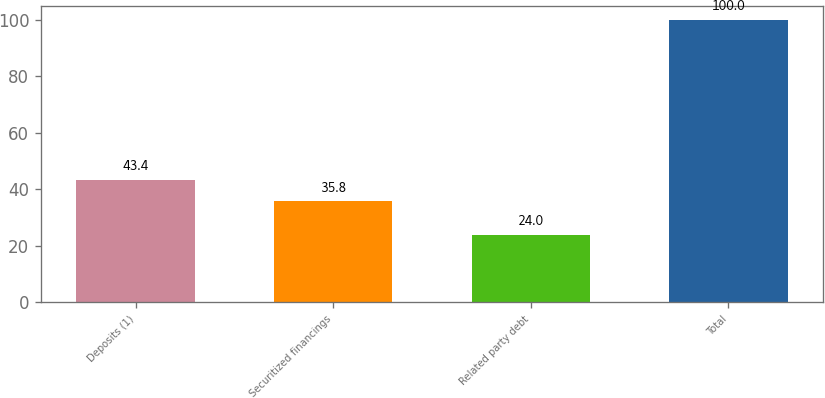Convert chart. <chart><loc_0><loc_0><loc_500><loc_500><bar_chart><fcel>Deposits (1)<fcel>Securitized financings<fcel>Related party debt<fcel>Total<nl><fcel>43.4<fcel>35.8<fcel>24<fcel>100<nl></chart> 